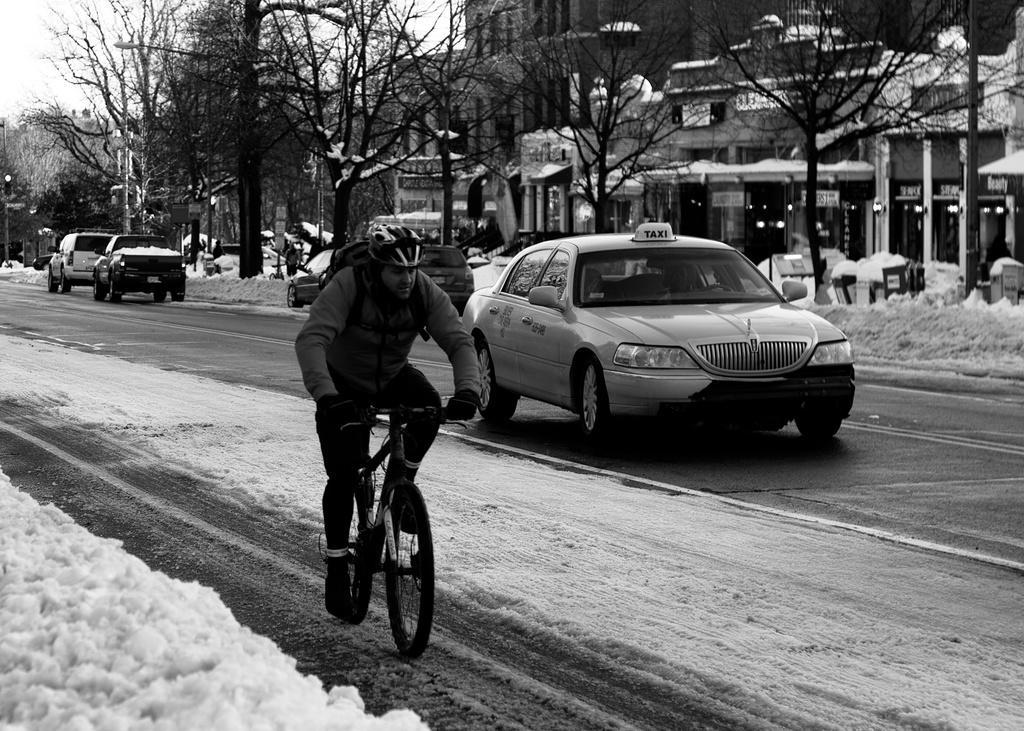Could you give a brief overview of what you see in this image? As we can see in the image there is a sky, dry trees, buildings, few cars on road a man is riding bicycle in the front. 